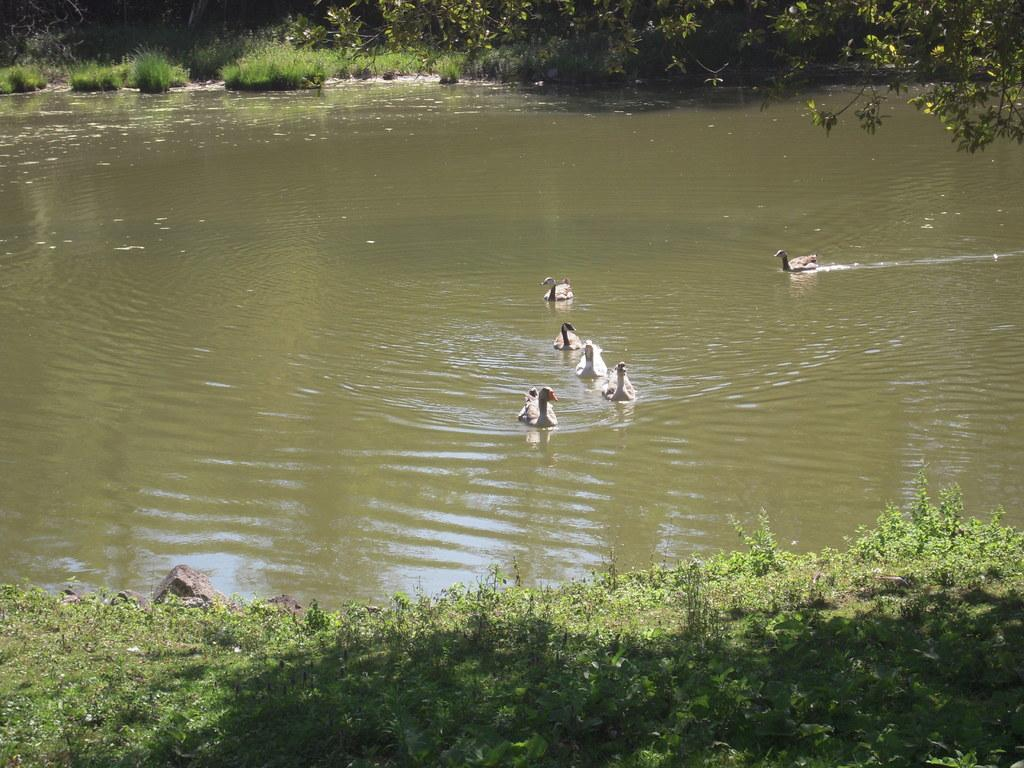What type of animals can be seen in the water in the image? There are birds in the water in the image. What type of vegetation can be seen at the bottom of the image? There is grass and plants visible at the bottom of the image. What type of vegetation can be seen at the top of the image? There is grass and plants visible at the top of the image, as well as a tree. Can you see a worm crawling on the tree in the image? There is no worm visible on the tree in the image. Is there a carriage being pulled by horses in the image? There is no carriage or horses present in the image. 